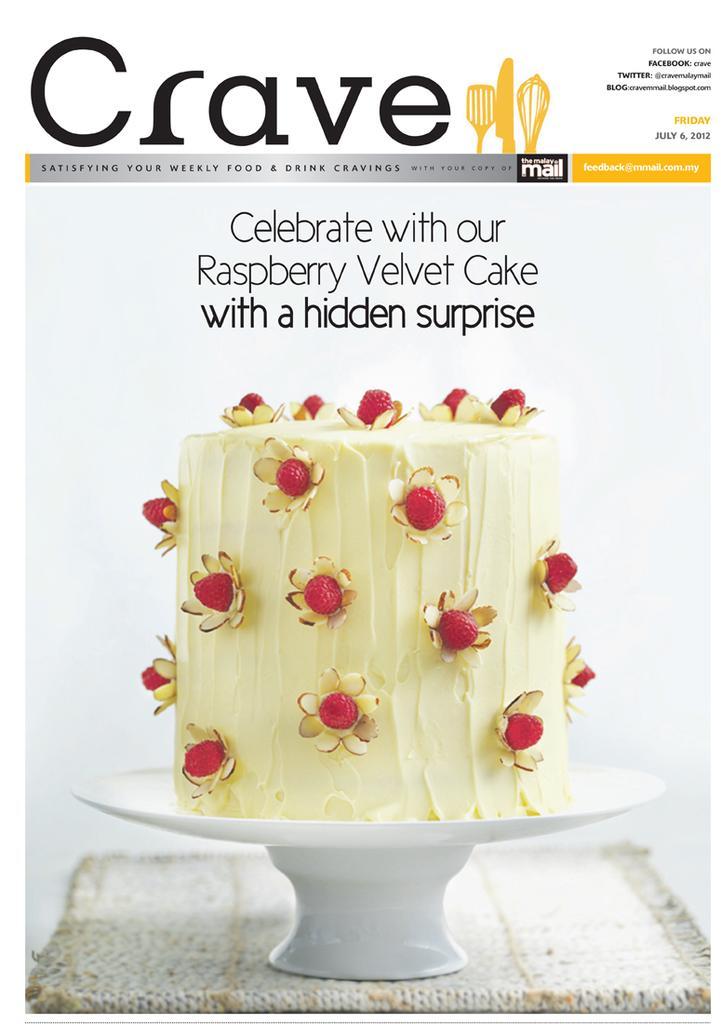Could you give a brief overview of what you see in this image? In the center of the image we can see a poster. On the poster, we can see a platform. On the platform, we can see a white color object. In that object, we can see some food item. At the top of the image, we can see some text. 